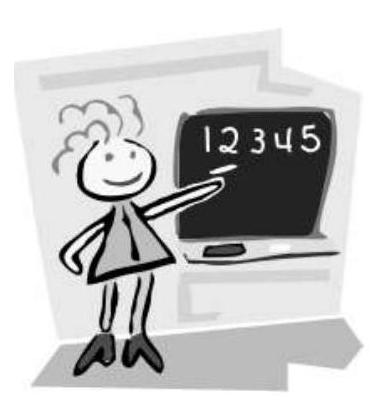Mary has written all the numbers from 1 to 30. How many times has she written digit 2? Mary wrote the digit '2' a total of 13 times from numbers 1 to 30. This digit appears in numbers like 2, 12, 20, 21, 22, 23, 24, 25, 26, 27, 28, and 29. Notice that 22 counts twice for the digit '2'. 